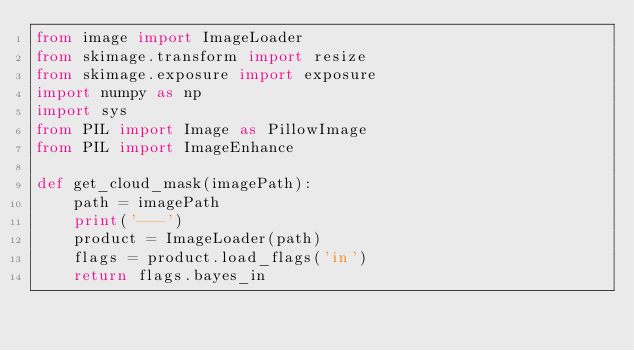Convert code to text. <code><loc_0><loc_0><loc_500><loc_500><_Python_>from image import ImageLoader
from skimage.transform import resize
from skimage.exposure import exposure
import numpy as np
import sys
from PIL import Image as PillowImage
from PIL import ImageEnhance

def get_cloud_mask(imagePath):
    path = imagePath
    print('---')
    product = ImageLoader(path)
    flags = product.load_flags('in')
    return flags.bayes_in</code> 